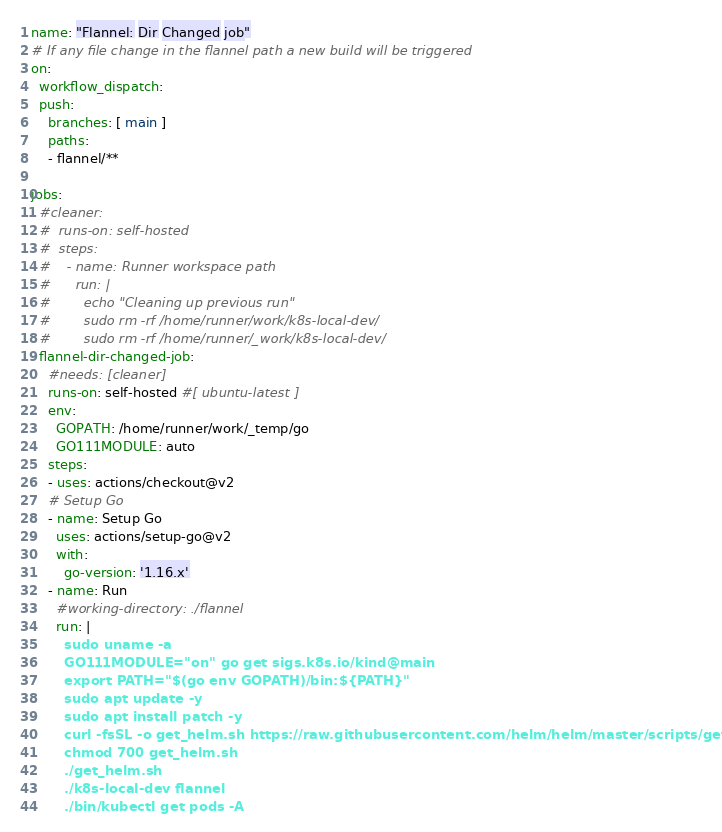Convert code to text. <code><loc_0><loc_0><loc_500><loc_500><_YAML_>name: "Flannel: Dir Changed job"
# If any file change in the flannel path a new build will be triggered
on:
  workflow_dispatch:
  push:
    branches: [ main ]
    paths:
    - flannel/**

jobs:
  #cleaner:
  #  runs-on: self-hosted
  #  steps:
  #    - name: Runner workspace path
  #      run: |
  #        echo "Cleaning up previous run"
  #        sudo rm -rf /home/runner/work/k8s-local-dev/
  #        sudo rm -rf /home/runner/_work/k8s-local-dev/
  flannel-dir-changed-job:
    #needs: [cleaner]
    runs-on: self-hosted #[ ubuntu-latest ]
    env:
      GOPATH: /home/runner/work/_temp/go
      GO111MODULE: auto
    steps:
    - uses: actions/checkout@v2
    # Setup Go
    - name: Setup Go
      uses: actions/setup-go@v2
      with:
        go-version: '1.16.x'
    - name: Run
      #working-directory: ./flannel
      run: |
        sudo uname -a
        GO111MODULE="on" go get sigs.k8s.io/kind@main
        export PATH="$(go env GOPATH)/bin:${PATH}"
        sudo apt update -y
        sudo apt install patch -y
        curl -fsSL -o get_helm.sh https://raw.githubusercontent.com/helm/helm/master/scripts/get-helm-3
        chmod 700 get_helm.sh
        ./get_helm.sh
        ./k8s-local-dev flannel
        ./bin/kubectl get pods -A
</code> 